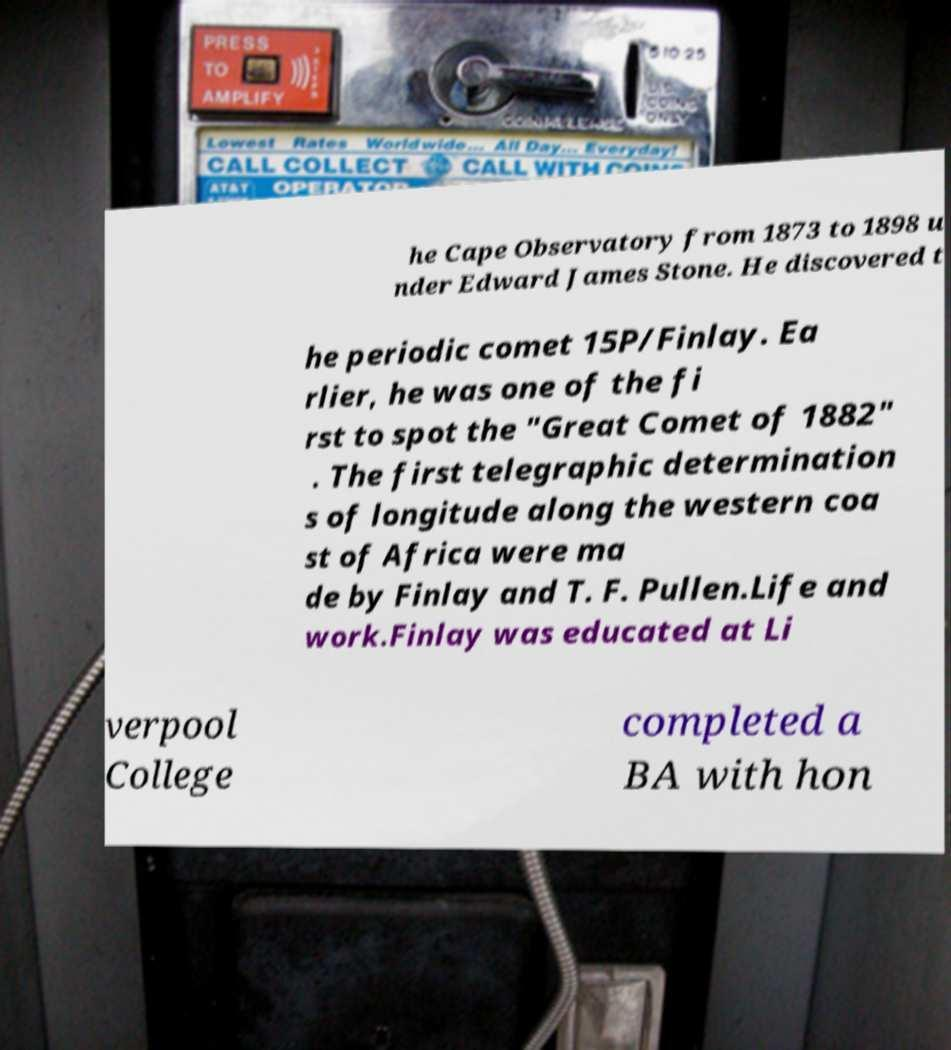Please identify and transcribe the text found in this image. he Cape Observatory from 1873 to 1898 u nder Edward James Stone. He discovered t he periodic comet 15P/Finlay. Ea rlier, he was one of the fi rst to spot the "Great Comet of 1882" . The first telegraphic determination s of longitude along the western coa st of Africa were ma de by Finlay and T. F. Pullen.Life and work.Finlay was educated at Li verpool College completed a BA with hon 